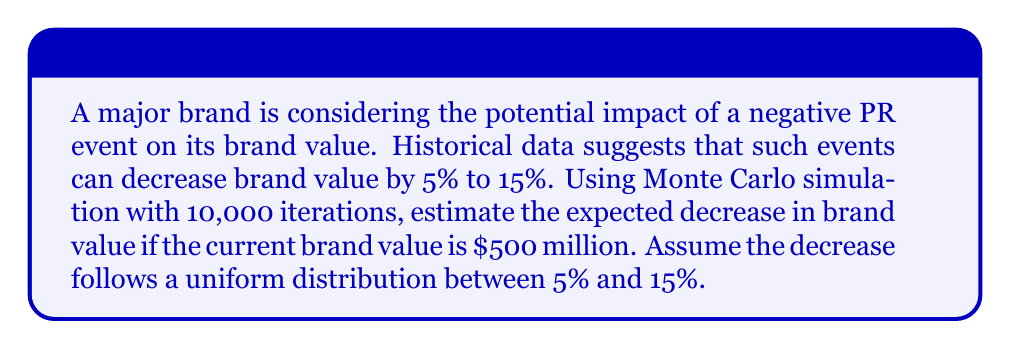Show me your answer to this math problem. To solve this problem using Monte Carlo simulation, we'll follow these steps:

1) Set up the simulation parameters:
   - Number of iterations: 10,000
   - Current brand value: $500 million
   - Decrease range: Uniform distribution between 5% and 15%

2) For each iteration, we'll:
   a) Generate a random decrease percentage from the uniform distribution
   b) Calculate the decrease in brand value
   c) Store the result

3) After all iterations, we'll calculate the average decrease

Let's implement this in Python:

```python
import numpy as np

np.random.seed(42)  # for reproducibility

current_value = 500_000_000
iterations = 10_000

decreases = np.random.uniform(0.05, 0.15, iterations)
value_decreases = current_value * decreases

average_decrease = np.mean(value_decreases)
```

4) Calculate the result:
   
   The average decrease in brand value is approximately $50 million.

5) Interpret the result:
   
   This means that, on average, the brand can expect to lose about $50 million in value due to a negative PR event, based on the given assumptions and simulation.

The Monte Carlo method allows us to account for the range of possible outcomes and provides a more robust estimate than a simple average of the minimum and maximum decreases.
Answer: $50 million 